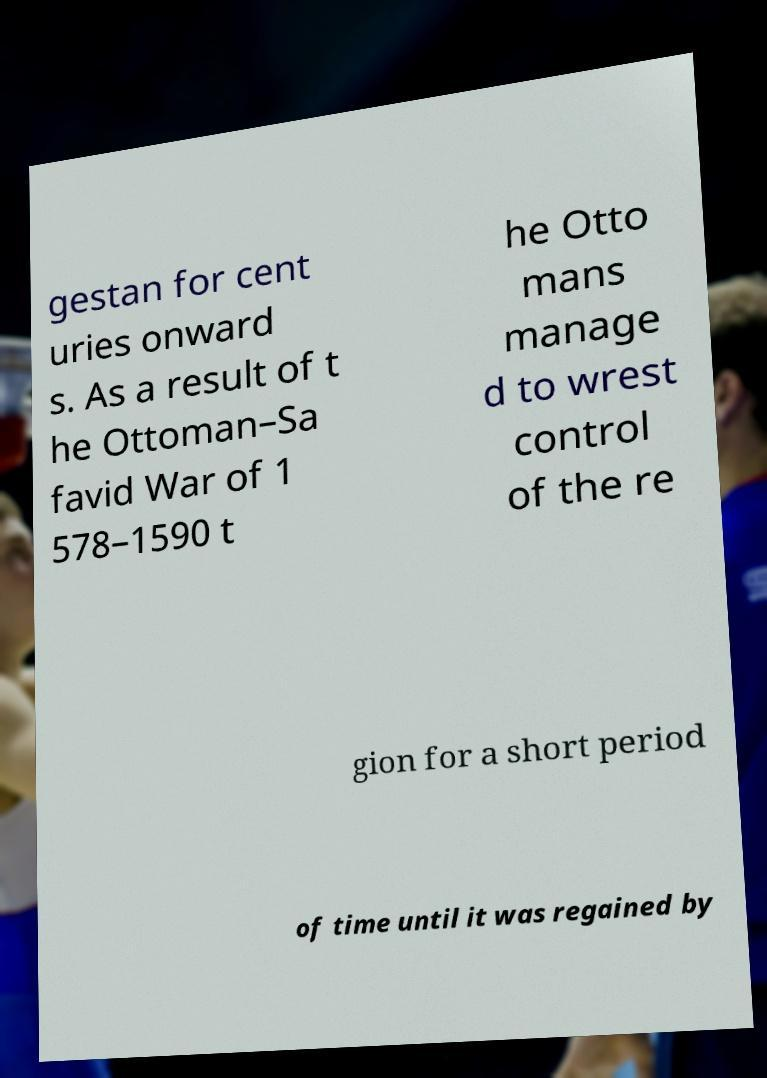Can you read and provide the text displayed in the image?This photo seems to have some interesting text. Can you extract and type it out for me? gestan for cent uries onward s. As a result of t he Ottoman–Sa favid War of 1 578–1590 t he Otto mans manage d to wrest control of the re gion for a short period of time until it was regained by 